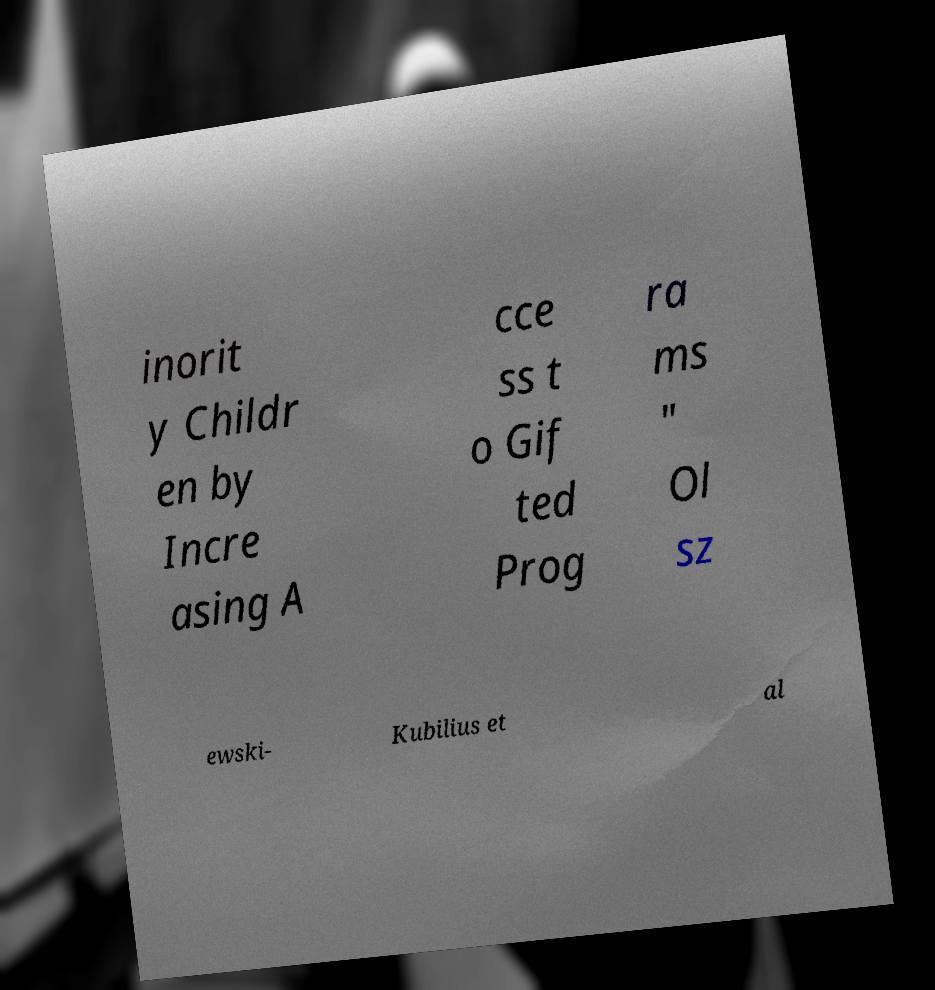Please identify and transcribe the text found in this image. inorit y Childr en by Incre asing A cce ss t o Gif ted Prog ra ms " Ol sz ewski- Kubilius et al 